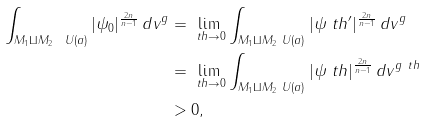<formula> <loc_0><loc_0><loc_500><loc_500>\int _ { { M _ { 1 } \amalg M _ { 2 } } \ U ( a ) } | \psi _ { 0 } | ^ { \frac { 2 n } { n - 1 } } \, d v ^ { g } & = \lim _ { \ t h \to 0 } \int _ { { M _ { 1 } \amalg M _ { 2 } } \ U ( a ) } | \psi _ { \ } t h ^ { \prime } | ^ { \frac { 2 n } { n - 1 } } \, d v ^ { g } \\ & = \lim _ { \ t h \to 0 } \int _ { { M _ { 1 } \amalg M _ { 2 } } \ U ( a ) } | \psi _ { \ } t h | ^ { \frac { 2 n } { n - 1 } } \, d v ^ { g _ { \ } t h } \\ & > 0 ,</formula> 